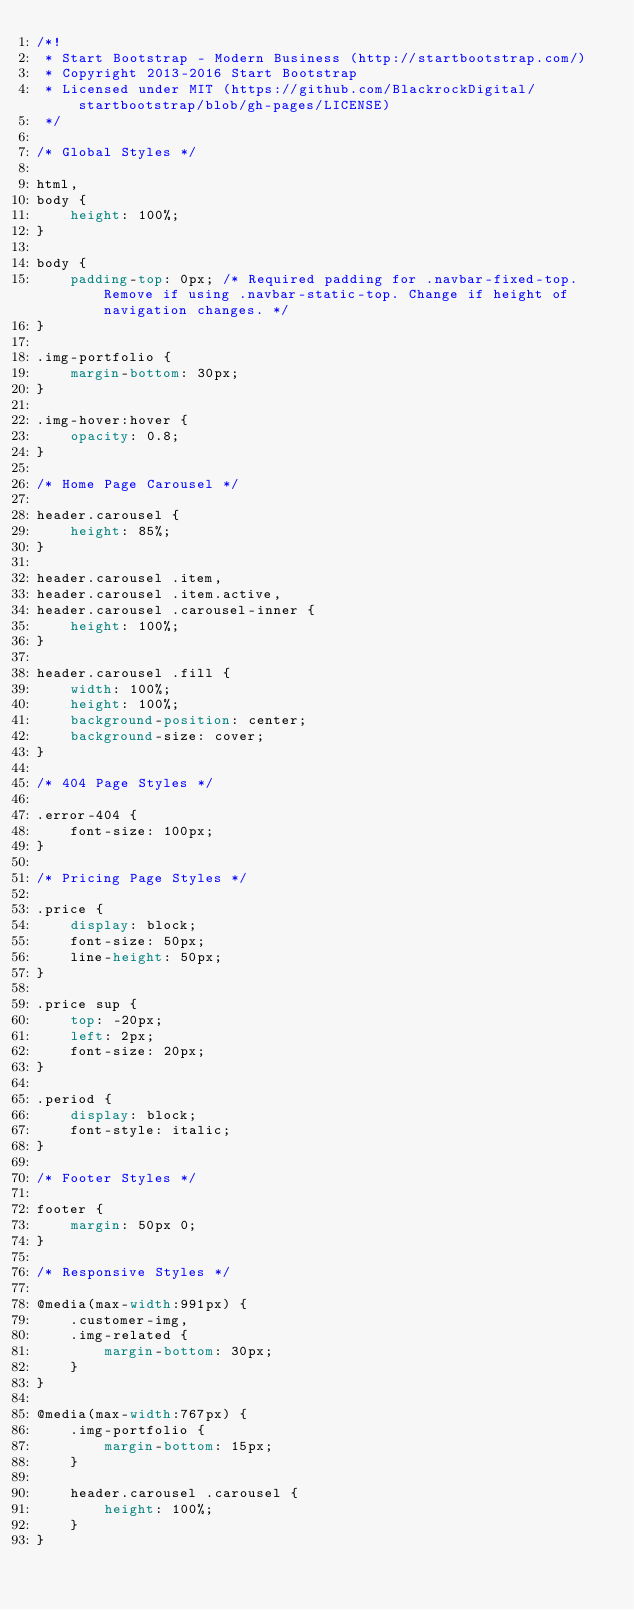<code> <loc_0><loc_0><loc_500><loc_500><_CSS_>/*!
 * Start Bootstrap - Modern Business (http://startbootstrap.com/)
 * Copyright 2013-2016 Start Bootstrap
 * Licensed under MIT (https://github.com/BlackrockDigital/startbootstrap/blob/gh-pages/LICENSE)
 */

/* Global Styles */

html,
body {
    height: 100%;
}

body {
    padding-top: 0px; /* Required padding for .navbar-fixed-top. Remove if using .navbar-static-top. Change if height of navigation changes. */
}

.img-portfolio {
    margin-bottom: 30px;
}

.img-hover:hover {
    opacity: 0.8;
}

/* Home Page Carousel */

header.carousel {
    height: 85%;
}

header.carousel .item,
header.carousel .item.active,
header.carousel .carousel-inner {
    height: 100%;
}

header.carousel .fill {
    width: 100%;
    height: 100%;
    background-position: center;
    background-size: cover;
}

/* 404 Page Styles */

.error-404 {
    font-size: 100px;
}

/* Pricing Page Styles */

.price {
    display: block;
    font-size: 50px;
    line-height: 50px;
}

.price sup {
    top: -20px;
    left: 2px;
    font-size: 20px;
}

.period {
    display: block;
    font-style: italic;
}

/* Footer Styles */

footer {
    margin: 50px 0;
}

/* Responsive Styles */

@media(max-width:991px) {
    .customer-img,
    .img-related {
        margin-bottom: 30px;
    }
}

@media(max-width:767px) {
    .img-portfolio {
        margin-bottom: 15px;
    }

    header.carousel .carousel {
        height: 100%;
    }
}</code> 